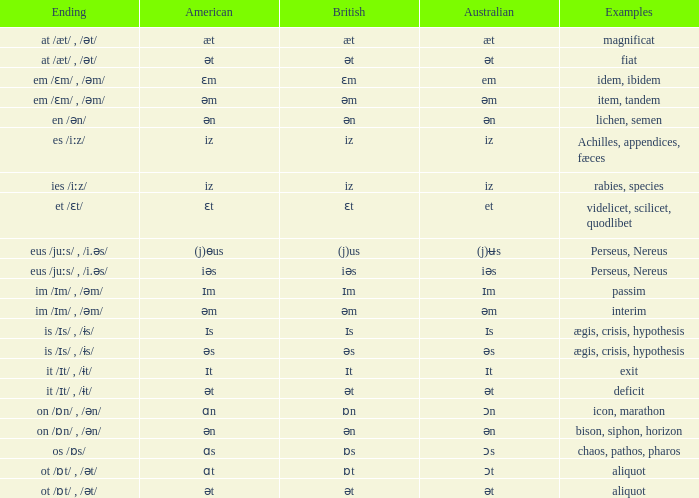Can you provide examples of exits in a british context? Ɪt. 